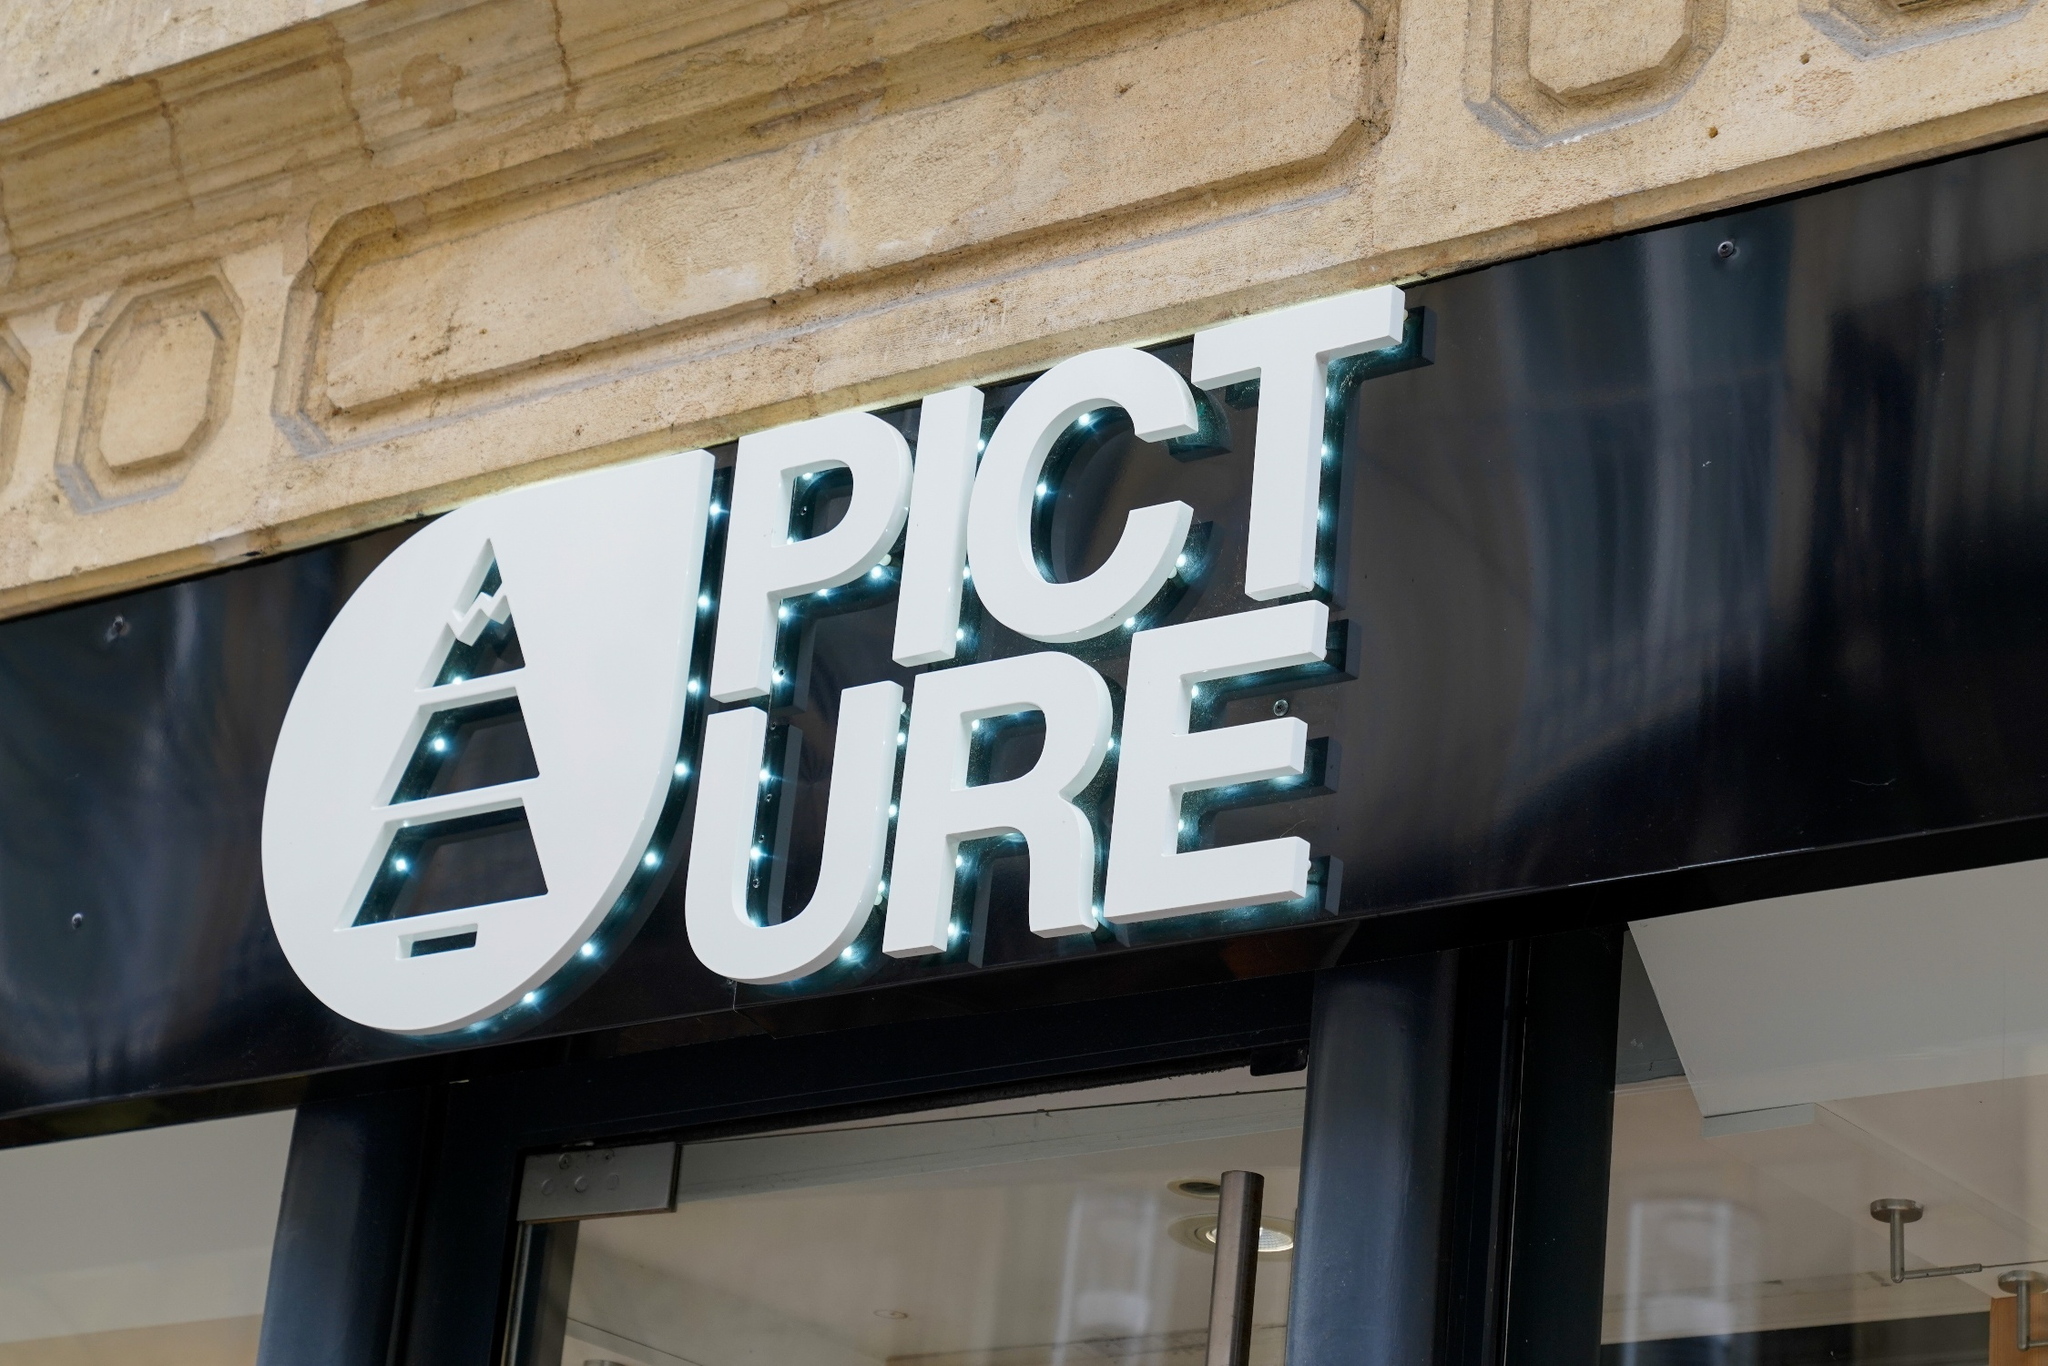What's happening in the scene? The scene features a sophisticated storefront that emphasizes a blend of modern and elegant design elements. Prominently above the entrance is a stylish sign that spells 'PICTURE' in white, contemporary letters. The letter 'A' is creatively represented as a triangle, adding a unique touch to the sign. The building's facade is made of stone and painted beige, contributing to the aesthetically pleasing and upscale appearance. While there is no visible activity in the image, the overall ambiance suggests an inviting space that awaits customers' arrival. 